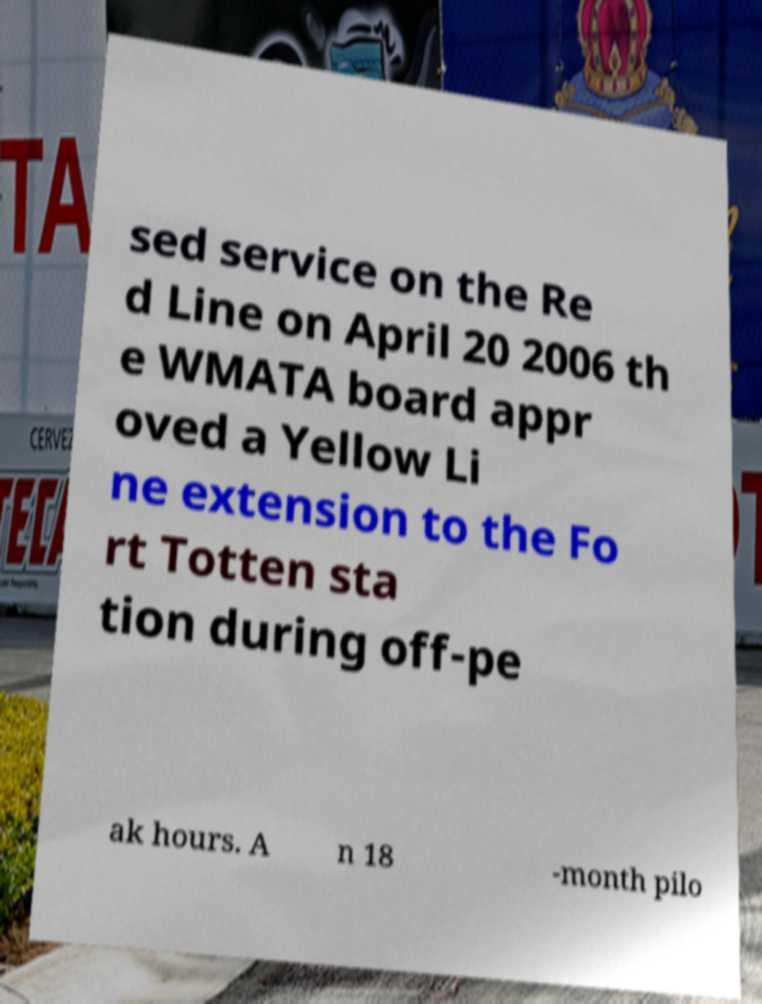Please read and relay the text visible in this image. What does it say? sed service on the Re d Line on April 20 2006 th e WMATA board appr oved a Yellow Li ne extension to the Fo rt Totten sta tion during off-pe ak hours. A n 18 -month pilo 